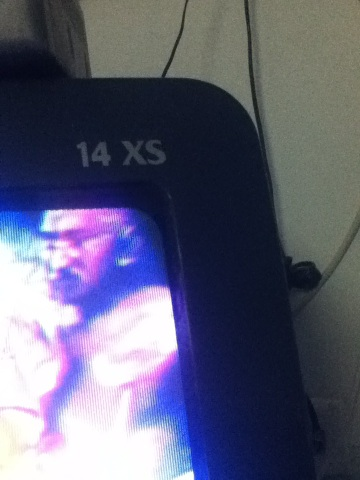What are the gentlemen in this video wearing? Due to the blurred and unclear nature of the image, it is challenging to distinguish specific clothing details. The image quality or angle might need improvement to provide a more precise answer. 